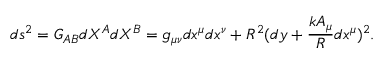Convert formula to latex. <formula><loc_0><loc_0><loc_500><loc_500>d s ^ { 2 } = G _ { A B } { d X ^ { A } } { d X ^ { B } } = g _ { \mu \nu } d x ^ { \mu } d x ^ { \nu } + R ^ { 2 } ( d y + \frac { k A _ { \mu } } { R } d x ^ { \mu } ) ^ { 2 } .</formula> 